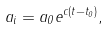<formula> <loc_0><loc_0><loc_500><loc_500>a _ { i } = a _ { 0 } e ^ { c ( t - t _ { 0 } ) } ,</formula> 